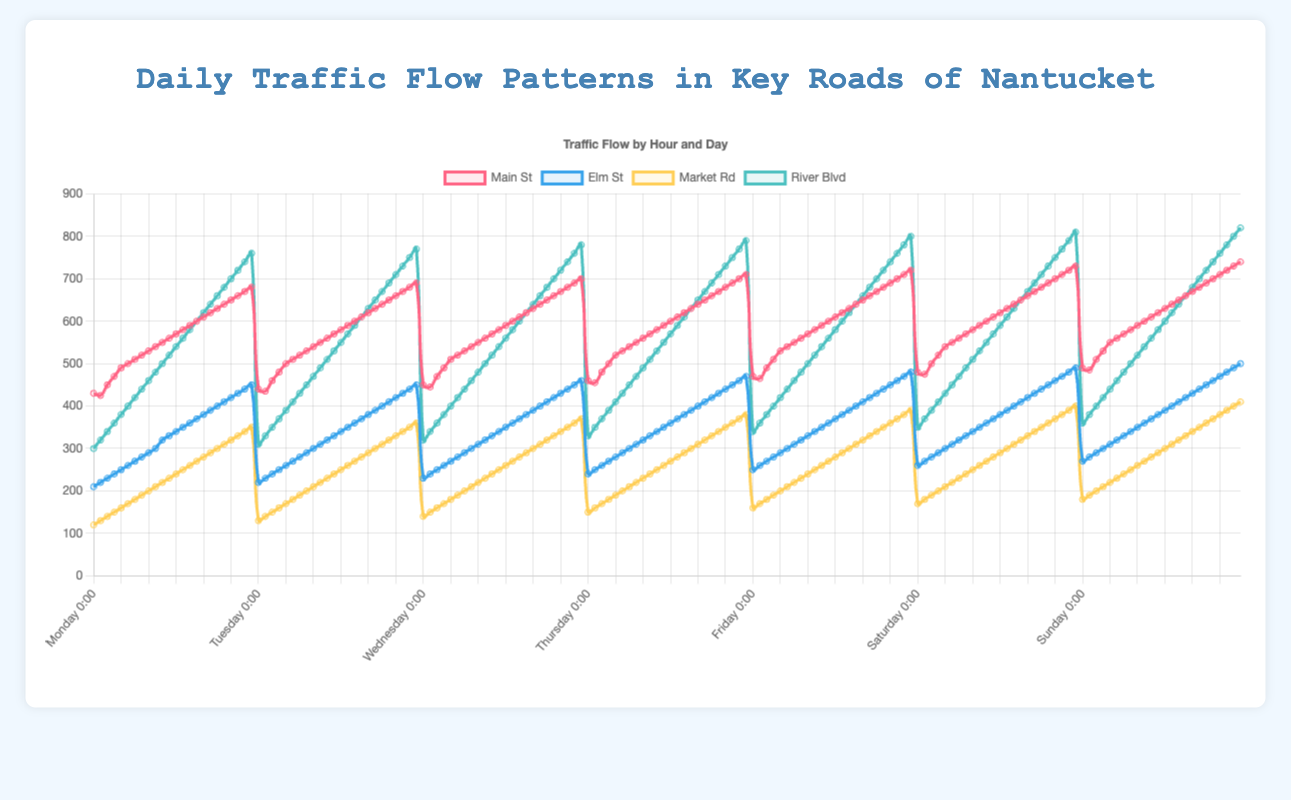What is the highest traffic flow recorded on Main St on Monday and at what time did it occur? To find this, look first at the maximum value on Main St for Monday. Main St on Monday data is \[430, 425, 450, 470, ... 680\]. The highest value is 680, which occurs at the last data point (23:00).
Answer: 680 at 23:00 On which day does Elm St have the lowest traffic flow at 15:00, and what is that value? Look at the 16th data point (15:00) for Elm St across all days. Elm St data for 15:00: Monday: 370, Tuesday: 380, Wednesday: 390, Thursday: 400, Friday: 410, Saturday: 420, Sunday: 430. The lowest value is 370 on Monday.
Answer: Monday with 370 Comparing the traffic flow at 08:00, which road has the highest traffic flow on Wednesday? Check the 9th value across all roads for Wednesday. Main St: 550, Elm St: 310, Market Rd: 210, River Blvd: 480. The highest traffic flow is on Main St with 550.
Answer: Main St with 550 What is the difference in traffic flow on River Blvd between 10:00 and 18:00 on Thursday? For Thursday, River Blvd data for 10:00 is the 11th value (530) and for 18:00 it is the 19th value (690). The difference is 690 - 530 = 160.
Answer: 160 How does the average traffic flow for Market Rd on Sunday compare to that on Saturday? Sum the traffic flow for Market Rd on both days and divide by 24. Sunday: (180 + 190 + ... + 410) = 7200/24 = 300, Saturday: (170 + 180 + ... + 400) = 7020/24 = 292.5. Sunday has a higher average.
Answer: Higher on Sunday What is the color coding used for Main St and Market Rd in the chart? Look at the colors represented in the legend for Main St and Market Rd. Main St is red and Market Rd is yellow.
Answer: Main St: red, Market Rd: yellow During which hour did Elm St record the highest increase in traffic flow from Tuesday to Wednesday? Calculate the difference for each hour between Tuesday and Wednesday for Elm St. The highest increase is observed at 23:00 from 450 to 460, an increase of 10.
Answer: 23:00 What are the overall trends in traffic flow on Main St across the week from morning to night? Observe the lines corresponding to Main St for each day. The general trend shows an increase in traffic flow as the day progresses from 430-490 (starting values) to 680-740 (ending values) over the week.
Answer: Increasing trend 